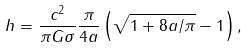Convert formula to latex. <formula><loc_0><loc_0><loc_500><loc_500>h = \frac { c ^ { 2 } } { \pi G \sigma } \frac { \pi } { 4 a } \left ( \sqrt { 1 + 8 a / \pi } - 1 \right ) ,</formula> 